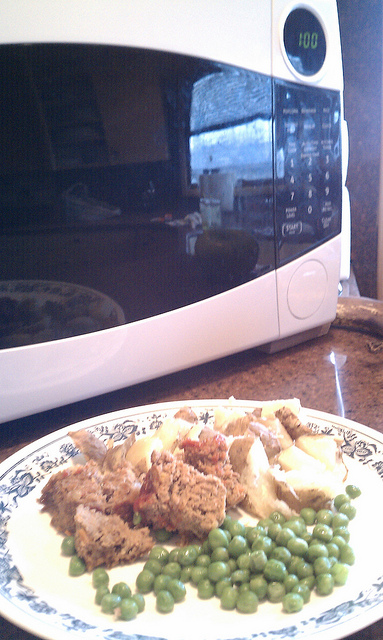Please transcribe the text in this image. 100 